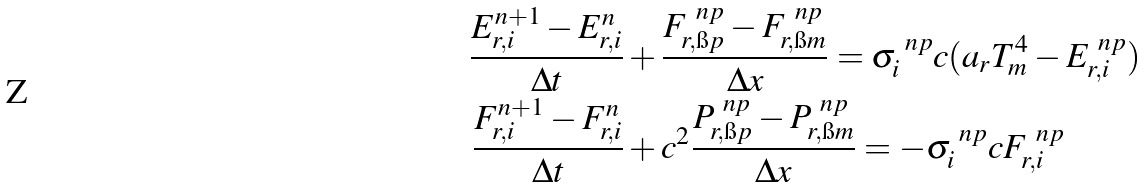Convert formula to latex. <formula><loc_0><loc_0><loc_500><loc_500>\frac { E ^ { n + 1 } _ { r , i } - E ^ { n } _ { r , i } } { \Delta t } & + \frac { F ^ { \ n p } _ { r , \i p } - F ^ { \ n p } _ { r , \i m } } { \Delta x } = \sigma ^ { \ n p } _ { i } c ( a _ { r } T _ { m } ^ { 4 } - E ^ { \ n p } _ { r , i } ) \\ \frac { F ^ { n + 1 } _ { r , i } - F ^ { n } _ { r , i } } { \Delta t } & + c ^ { 2 } \frac { P ^ { \ n p } _ { r , \i p } - P ^ { \ n p } _ { r , \i m } } { \Delta x } = - \sigma ^ { \ n p } _ { i } c F ^ { \ n p } _ { r , i }</formula> 